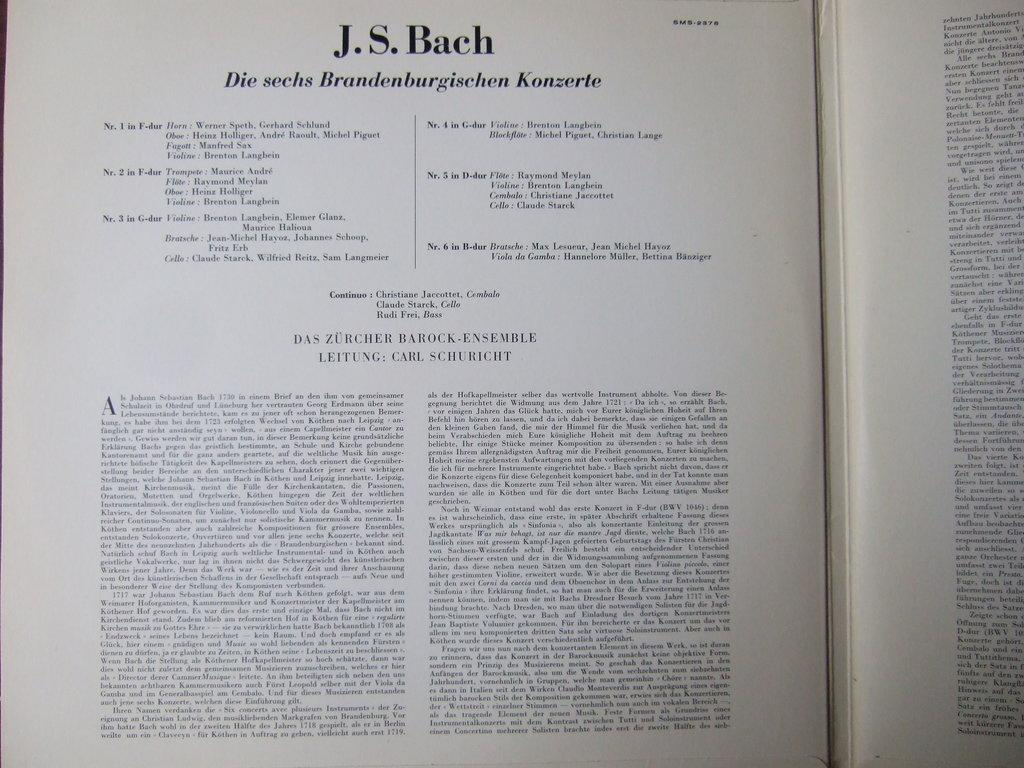<image>
Describe the image concisely. A open book with the page title reading J.S. Bach. 